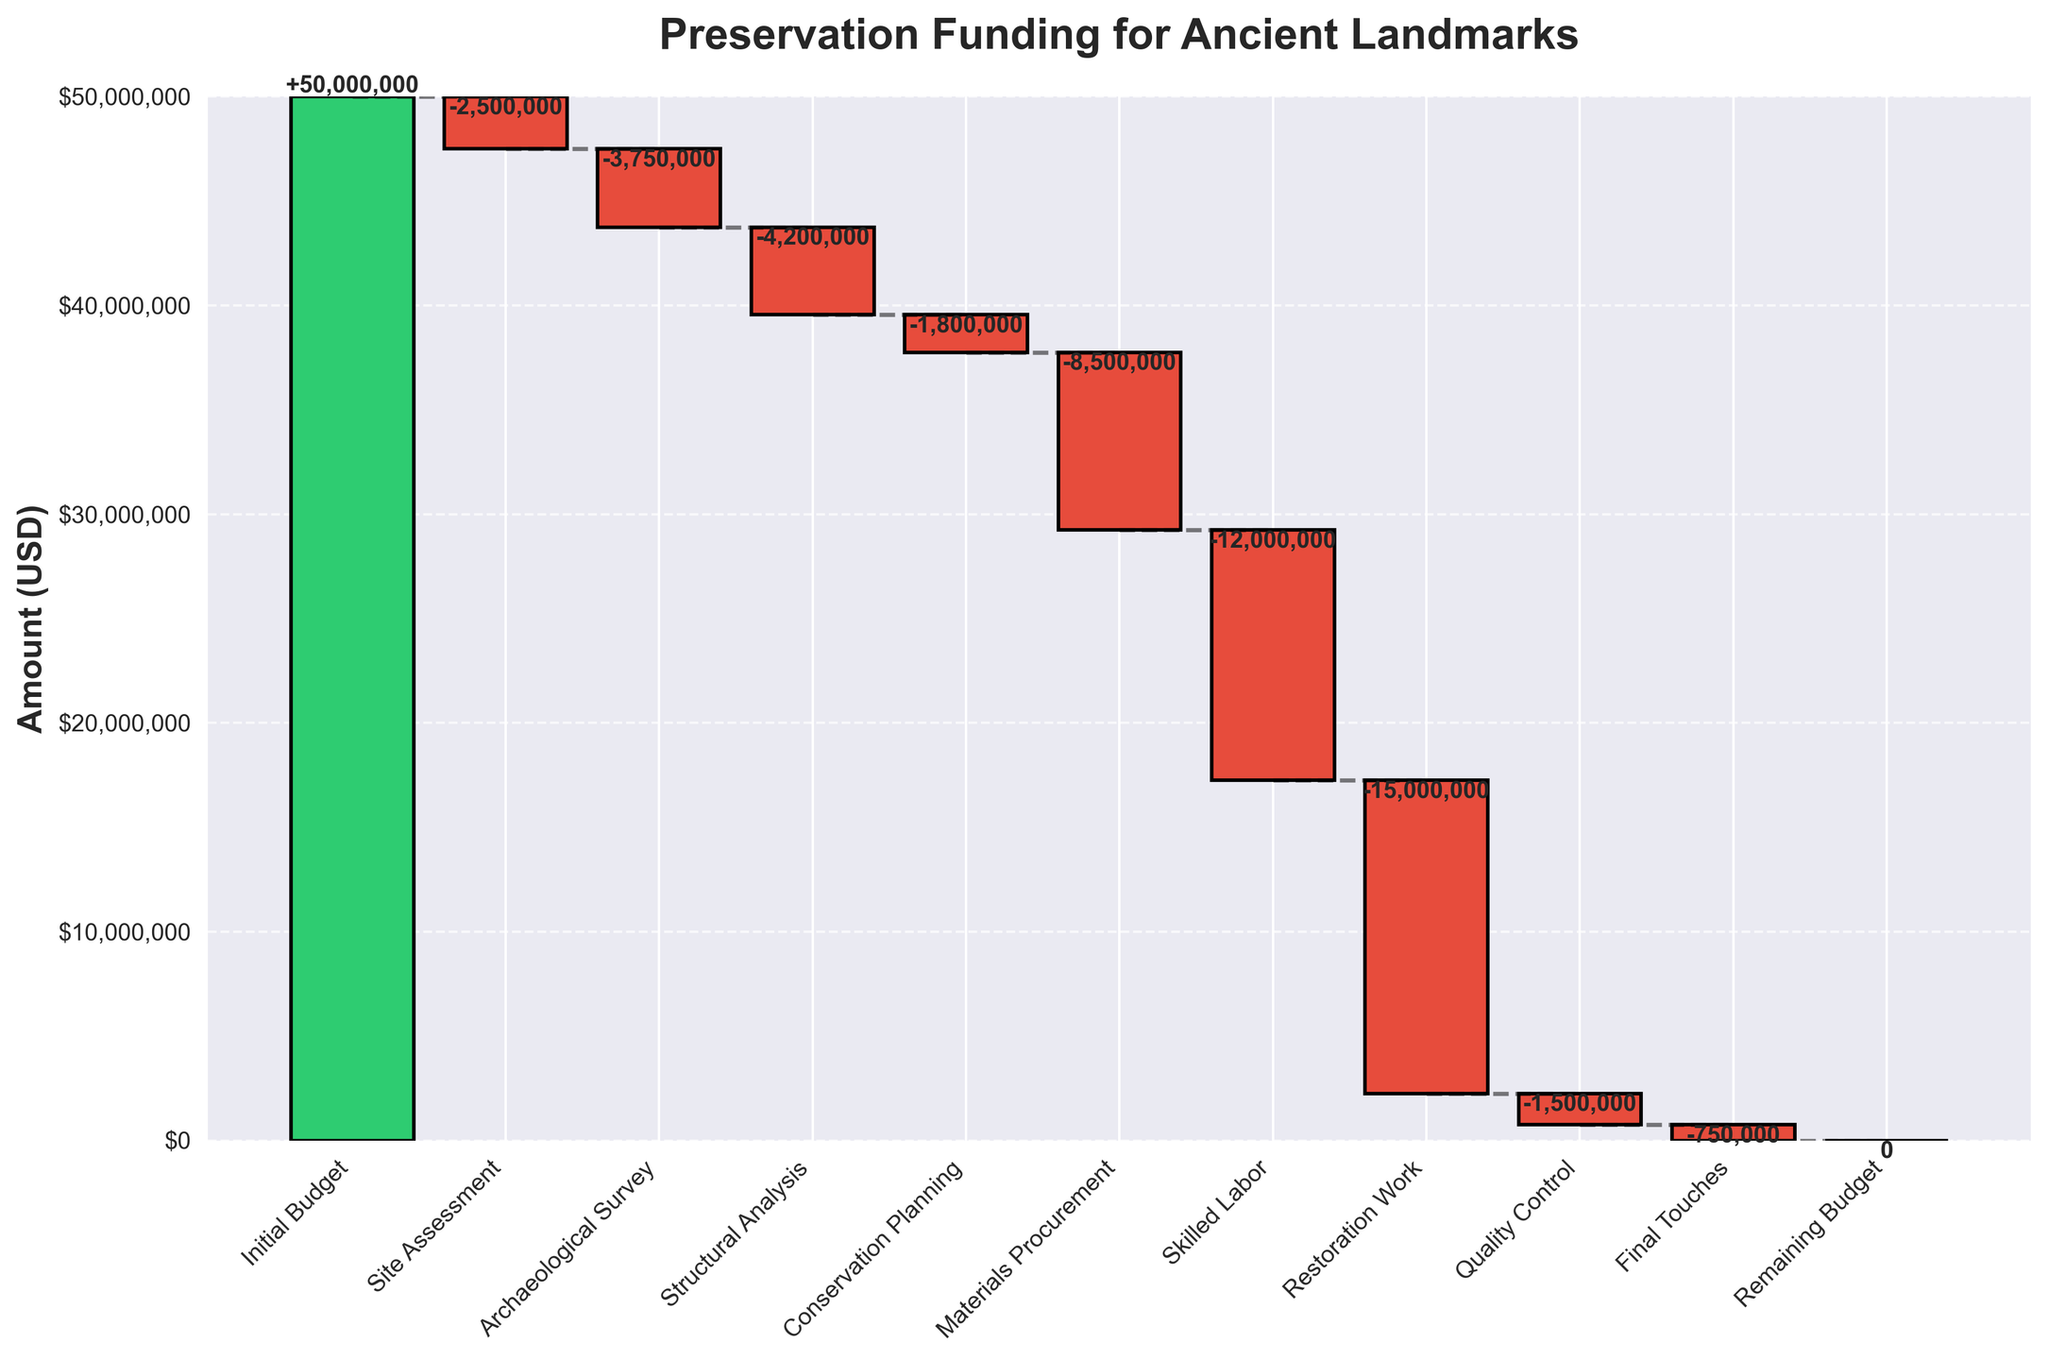What is the title of the chart? The title of the chart is displayed prominently at the top of the figure. It summarizes the main focus of the chart.
Answer: Preservation Funding for Ancient Landmarks What is the amount allocated for the Initial Budget phase? The Initial Budget phase is the first bar in the waterfall chart, which represents the starting amount. The value written inside this bar indicates the total initial budget.
Answer: $50,000,000 What phase has the greatest expenditure? In a waterfall chart, the phase with the greatest expenditure will have the highest negative value (indicated by the tallest red bar). By comparing the value labels on the red bars, the phase with the largest negative number can be identified.
Answer: Restoration Work If you add the amounts spent on Site Assessment and Archaeological Survey, what is the total? To find the total amount spent on both phases, sum the negative values of Site Assessment and Archaeological Survey from the chart. Site Assessment is -2,500,000 and Archaeological Survey is -3,750,000. Adding these together gives -2,500,000 + -3,750,000.
Answer: -6,250,000 Which phase occurs immediately after Structural Analysis? By following the phases on the x-axis from left to right, the phase that comes right after the Structural Analysis bar can be identified.
Answer: Conservation Planning What is the cumulative budget after the Archaeological Survey phase? To find the cumulative budget after a specific phase, sum the initial budget and all preceding expenditures up to that phase. Start with $50,000,000 (Initial Budget), then subtract the values for Site Assessment (-2,500,000) and Archaeological Survey (-3,750,000). Calculation: $50,000,000 - $2,500,000 - $3,750,000.
Answer: $43,750,000 How much is the final deficit or surplus represented in the Remaining Budget phase? The Remaining Budget is the last phase in the plot. Its value shows if there’s any surplus or deficit left at the end of all expenditures. The bar for Remaining Budget shows $0, indicating no surplus or deficit.
Answer: 0 Which two phases have the smallest expenditures? To identify the two phases with the smallest expenditures, compare the negative values of the red bars. The smallest absolute values represent the smallest expenditures.
Answer: Quality Control and Final Touches Is the amount spent on Skilled Labor greater or less than the amount spent on Materials Procurement? Compare the height (and value) of the bars for Skilled Labor and Materials Procurement. Skilled Labor has -12,000,000, whereas Materials Procurement has -8,500,000. Since -12,000,000 is more negative than -8,500,000, Skilled Labor has a greater expenditure.
Answer: Greater What is the financial difference between the Structural Analysis and Conservation Planning phases? To find the financial difference, subtract the amount spent on Conservation Planning (-1,800,000) from the amount spent on Structural Analysis (-4,200,000). Calculation: -4,200,000 - (-1,800,000). This simplifies to -4,200,000 + 1,800,000.
Answer: -2,400,000 